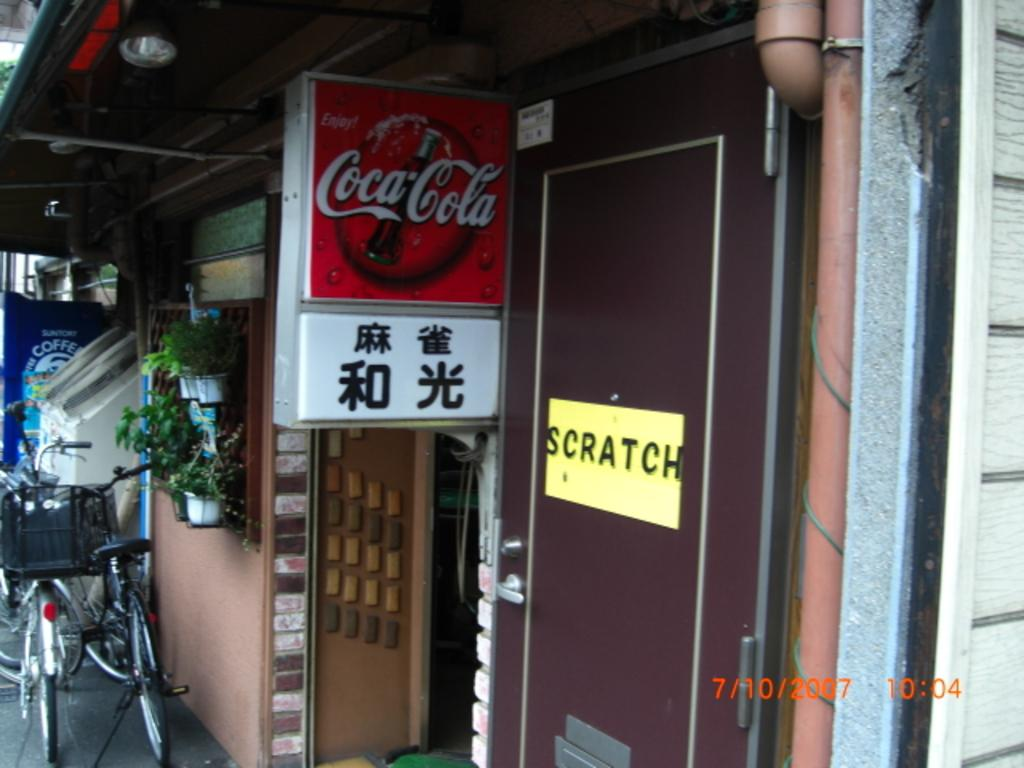What type of objects are on the right side of the image? There are plants with pots on the right side of the image. What can be seen on a door in the image? There is a yellow board on a door in the image. What type of advertisements are present in the image? There are hoardings in the image. What is a long, narrow object visible in the image? There is a pipe in the image. What type of transportation can be seen in the image? There are bicycles in the image. How many buns are sitting on the bicycles in the image? There are no buns present in the image; it features plants, a yellow board, hoardings, a pipe, and bicycles. What type of creatures are crawling on the hoardings in the image? There are no creatures, including spiders, crawling on the hoardings in the image. 